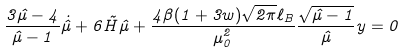<formula> <loc_0><loc_0><loc_500><loc_500>\frac { 3 \hat { \mu } - 4 } { \hat { \mu } - 1 } \dot { \hat { \mu } } + 6 \tilde { H } \hat { \mu } + \frac { 4 \beta ( 1 + 3 w ) \sqrt { 2 \pi } \ell _ { B } } { \mu _ { 0 } ^ { 2 } } \frac { \sqrt { \hat { \mu } - 1 } } { \hat { \mu } } y = 0</formula> 